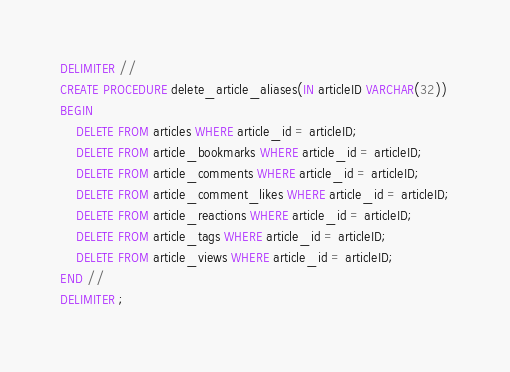Convert code to text. <code><loc_0><loc_0><loc_500><loc_500><_SQL_>DELIMITER //
CREATE PROCEDURE delete_article_aliases(IN articleID VARCHAR(32))
BEGIN
	DELETE FROM articles WHERE article_id = articleID;
	DELETE FROM article_bookmarks WHERE article_id = articleID;
	DELETE FROM article_comments WHERE article_id = articleID;
	DELETE FROM article_comment_likes WHERE article_id = articleID;
	DELETE FROM article_reactions WHERE article_id = articleID;
	DELETE FROM article_tags WHERE article_id = articleID;
	DELETE FROM article_views WHERE article_id = articleID;
END //
DELIMITER ;</code> 